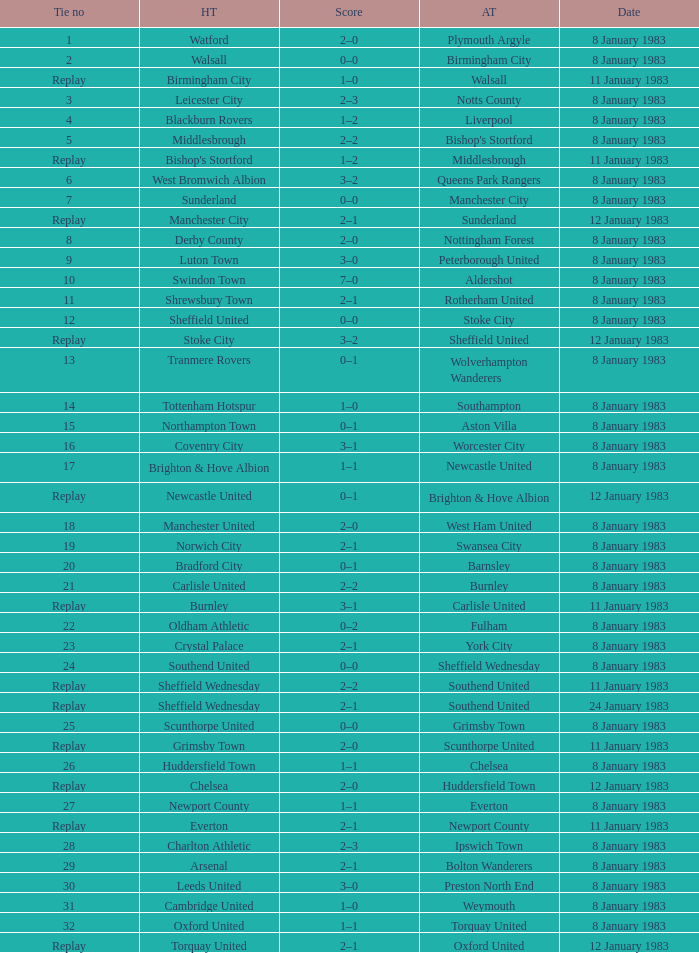On what date was Tie #26 played? 8 January 1983. 